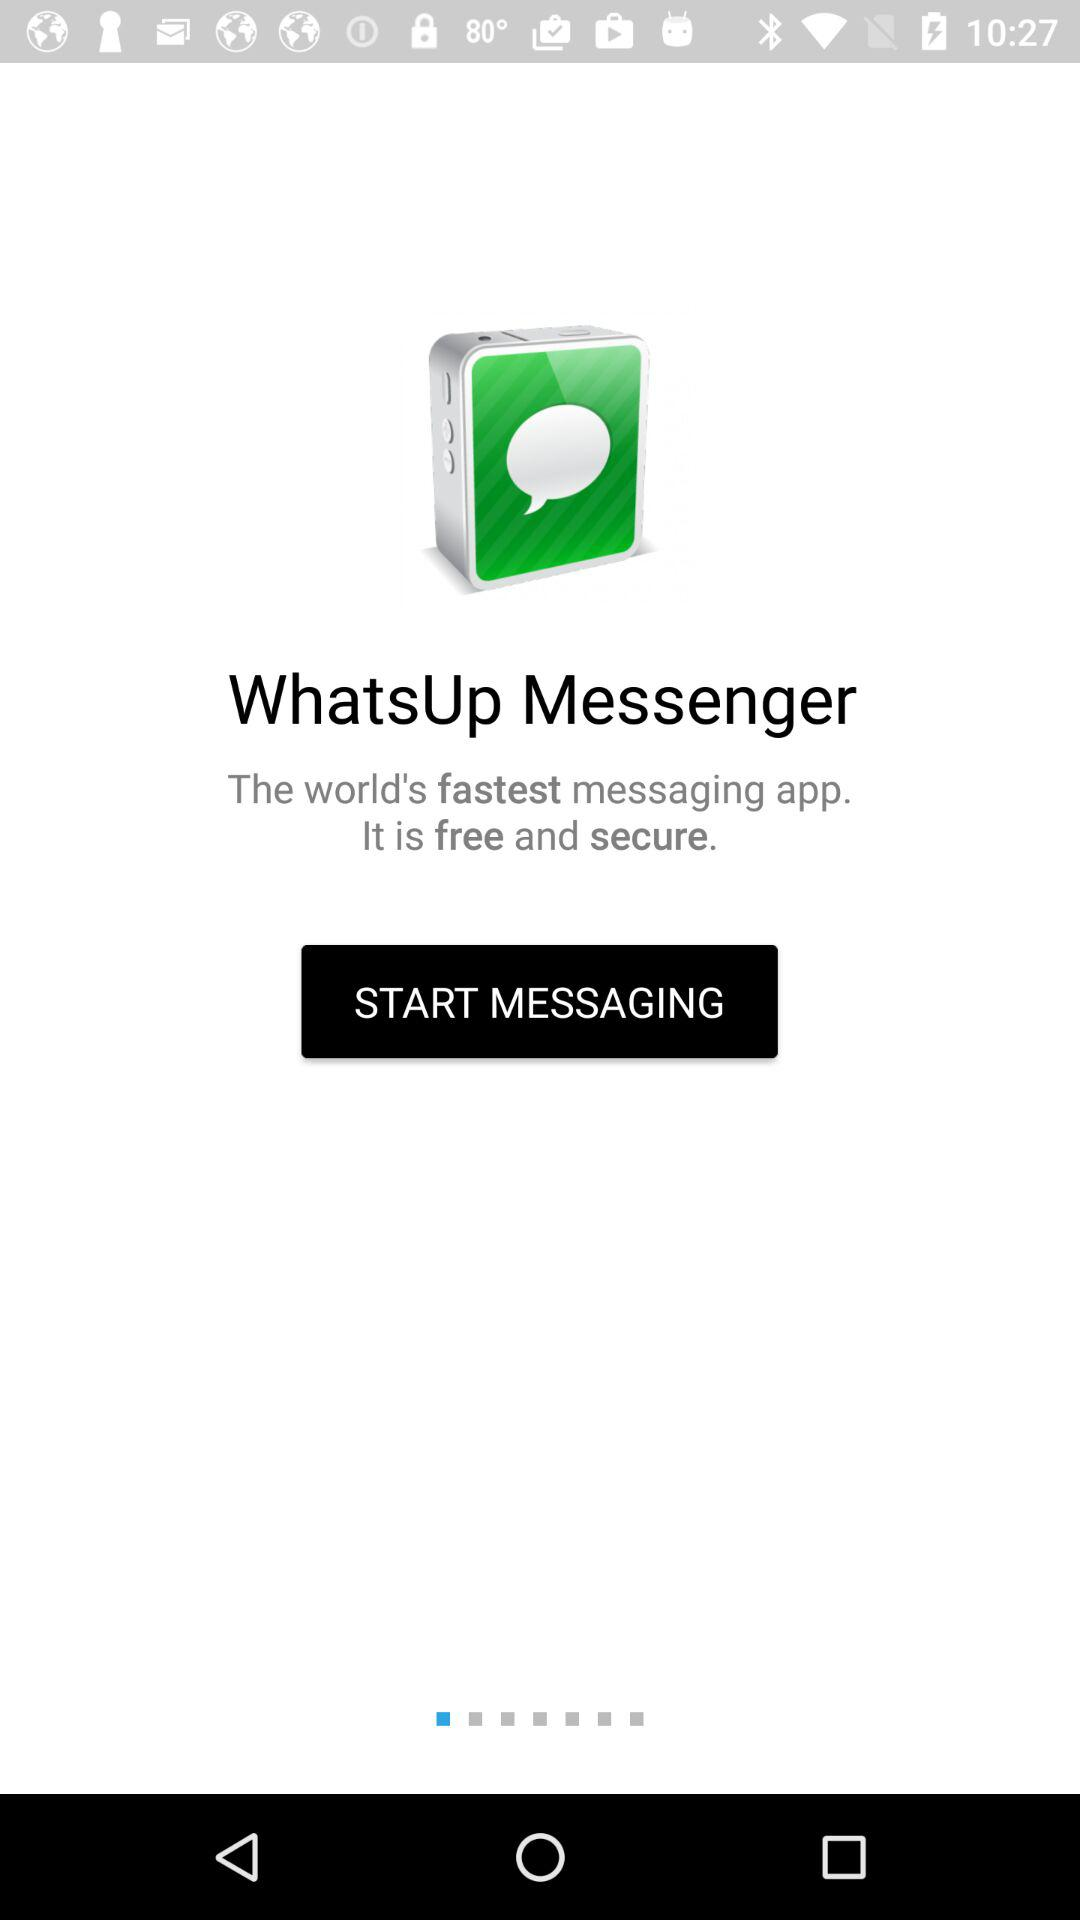What is the name of the application? The name of the application is "WhatsUp Messenger". 